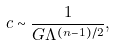Convert formula to latex. <formula><loc_0><loc_0><loc_500><loc_500>c \sim \frac { 1 } { G \Lambda ^ { ( n - 1 ) / 2 } } ,</formula> 